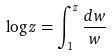Convert formula to latex. <formula><loc_0><loc_0><loc_500><loc_500>\log z = \int _ { 1 } ^ { z } \frac { d w } { w }</formula> 